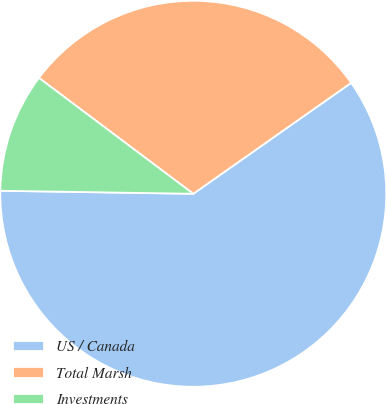Convert chart to OTSL. <chart><loc_0><loc_0><loc_500><loc_500><pie_chart><fcel>US / Canada<fcel>Total Marsh<fcel>Investments<nl><fcel>60.0%<fcel>30.0%<fcel>10.0%<nl></chart> 